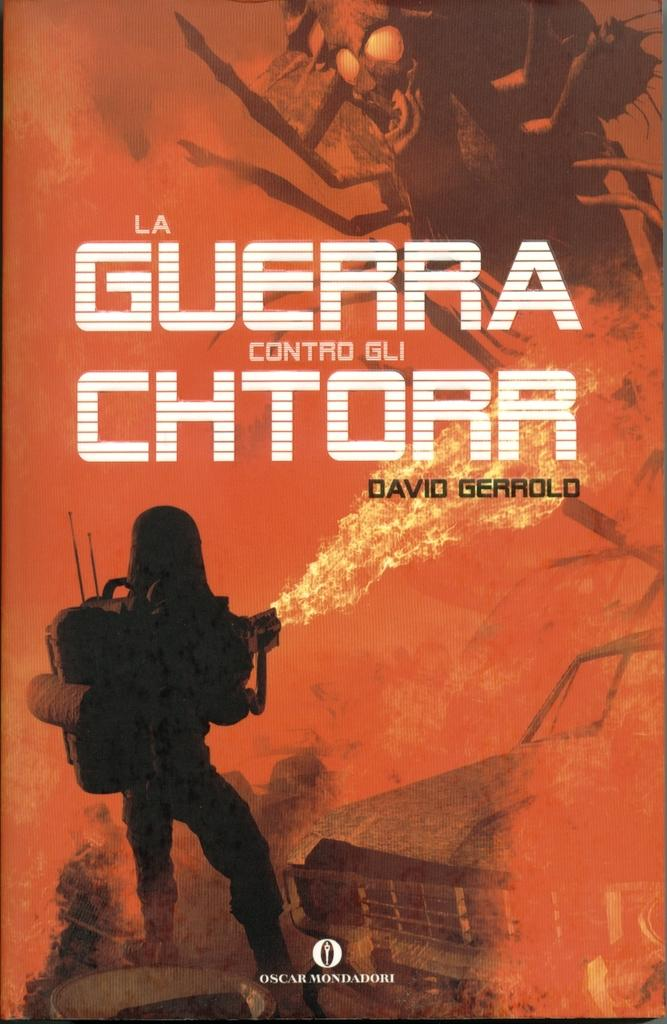<image>
Share a concise interpretation of the image provided. David Gerrold wrote the book La Guerra Contro Gli Chtorr. 